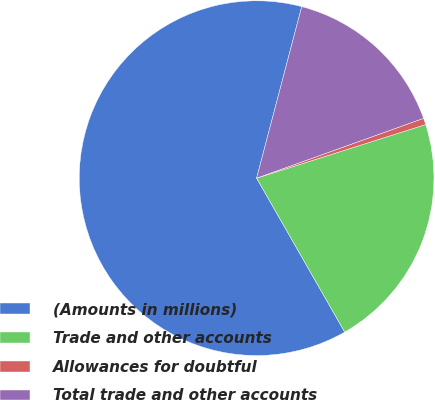Convert chart to OTSL. <chart><loc_0><loc_0><loc_500><loc_500><pie_chart><fcel>(Amounts in millions)<fcel>Trade and other accounts<fcel>Allowances for doubtful<fcel>Total trade and other accounts<nl><fcel>62.37%<fcel>21.61%<fcel>0.59%<fcel>15.43%<nl></chart> 